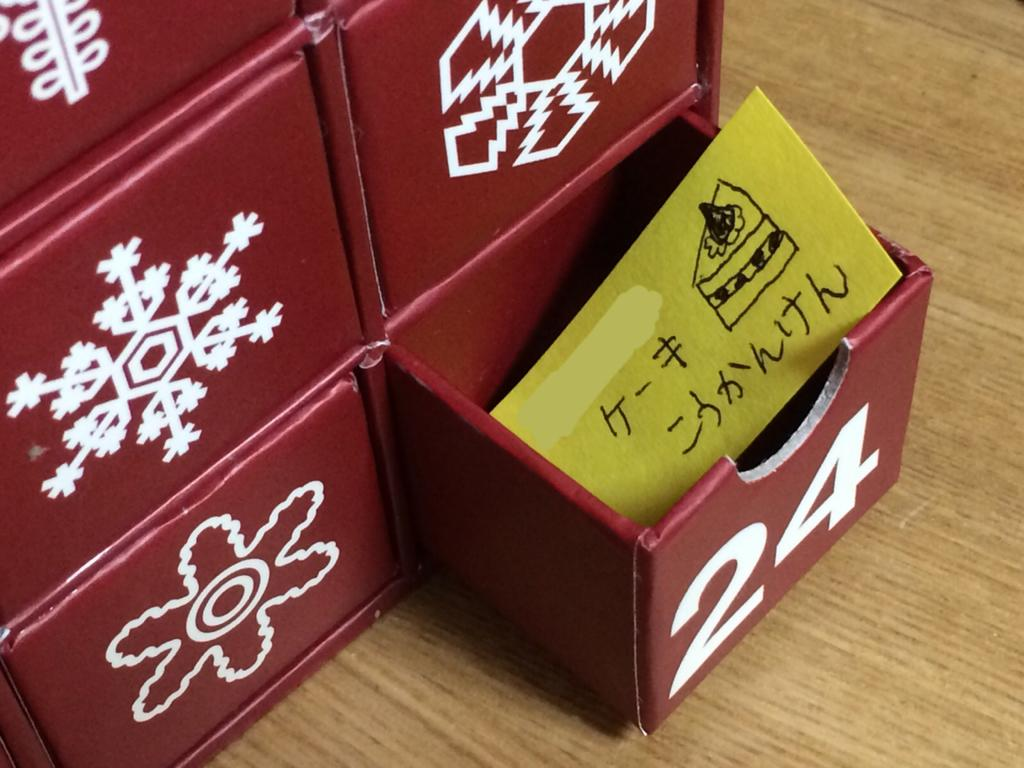What type of furniture is present in the image? There are cabinets in the image. What color are the cabinets? The cabinets are red in color. Do the cabinets have any unique features? Yes, the cabinets have patterns. What can be found on one of the cabinet shelves? There is a card with text on one of the cabinet shelves. What is visible beneath the cabinets? There is a floor visible in the image. Can you see the moon in the image? No, the moon is not present in the image. Is there a wound visible on any of the cabinets? No, there are no wounds visible on the cabinets or any other objects in the image. 